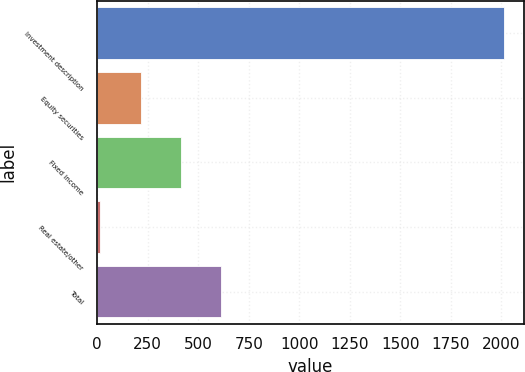<chart> <loc_0><loc_0><loc_500><loc_500><bar_chart><fcel>Investment description<fcel>Equity securities<fcel>Fixed income<fcel>Real estate/other<fcel>Total<nl><fcel>2013<fcel>214.8<fcel>414.6<fcel>15<fcel>614.4<nl></chart> 